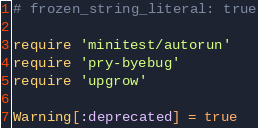<code> <loc_0><loc_0><loc_500><loc_500><_Ruby_># frozen_string_literal: true

require 'minitest/autorun'
require 'pry-byebug'
require 'upgrow'

Warning[:deprecated] = true
</code> 